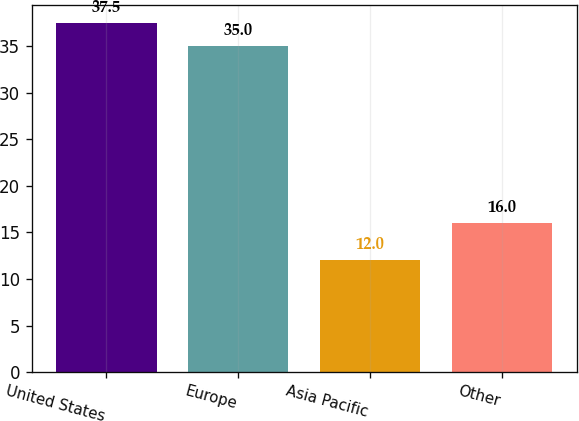<chart> <loc_0><loc_0><loc_500><loc_500><bar_chart><fcel>United States<fcel>Europe<fcel>Asia Pacific<fcel>Other<nl><fcel>37.5<fcel>35<fcel>12<fcel>16<nl></chart> 